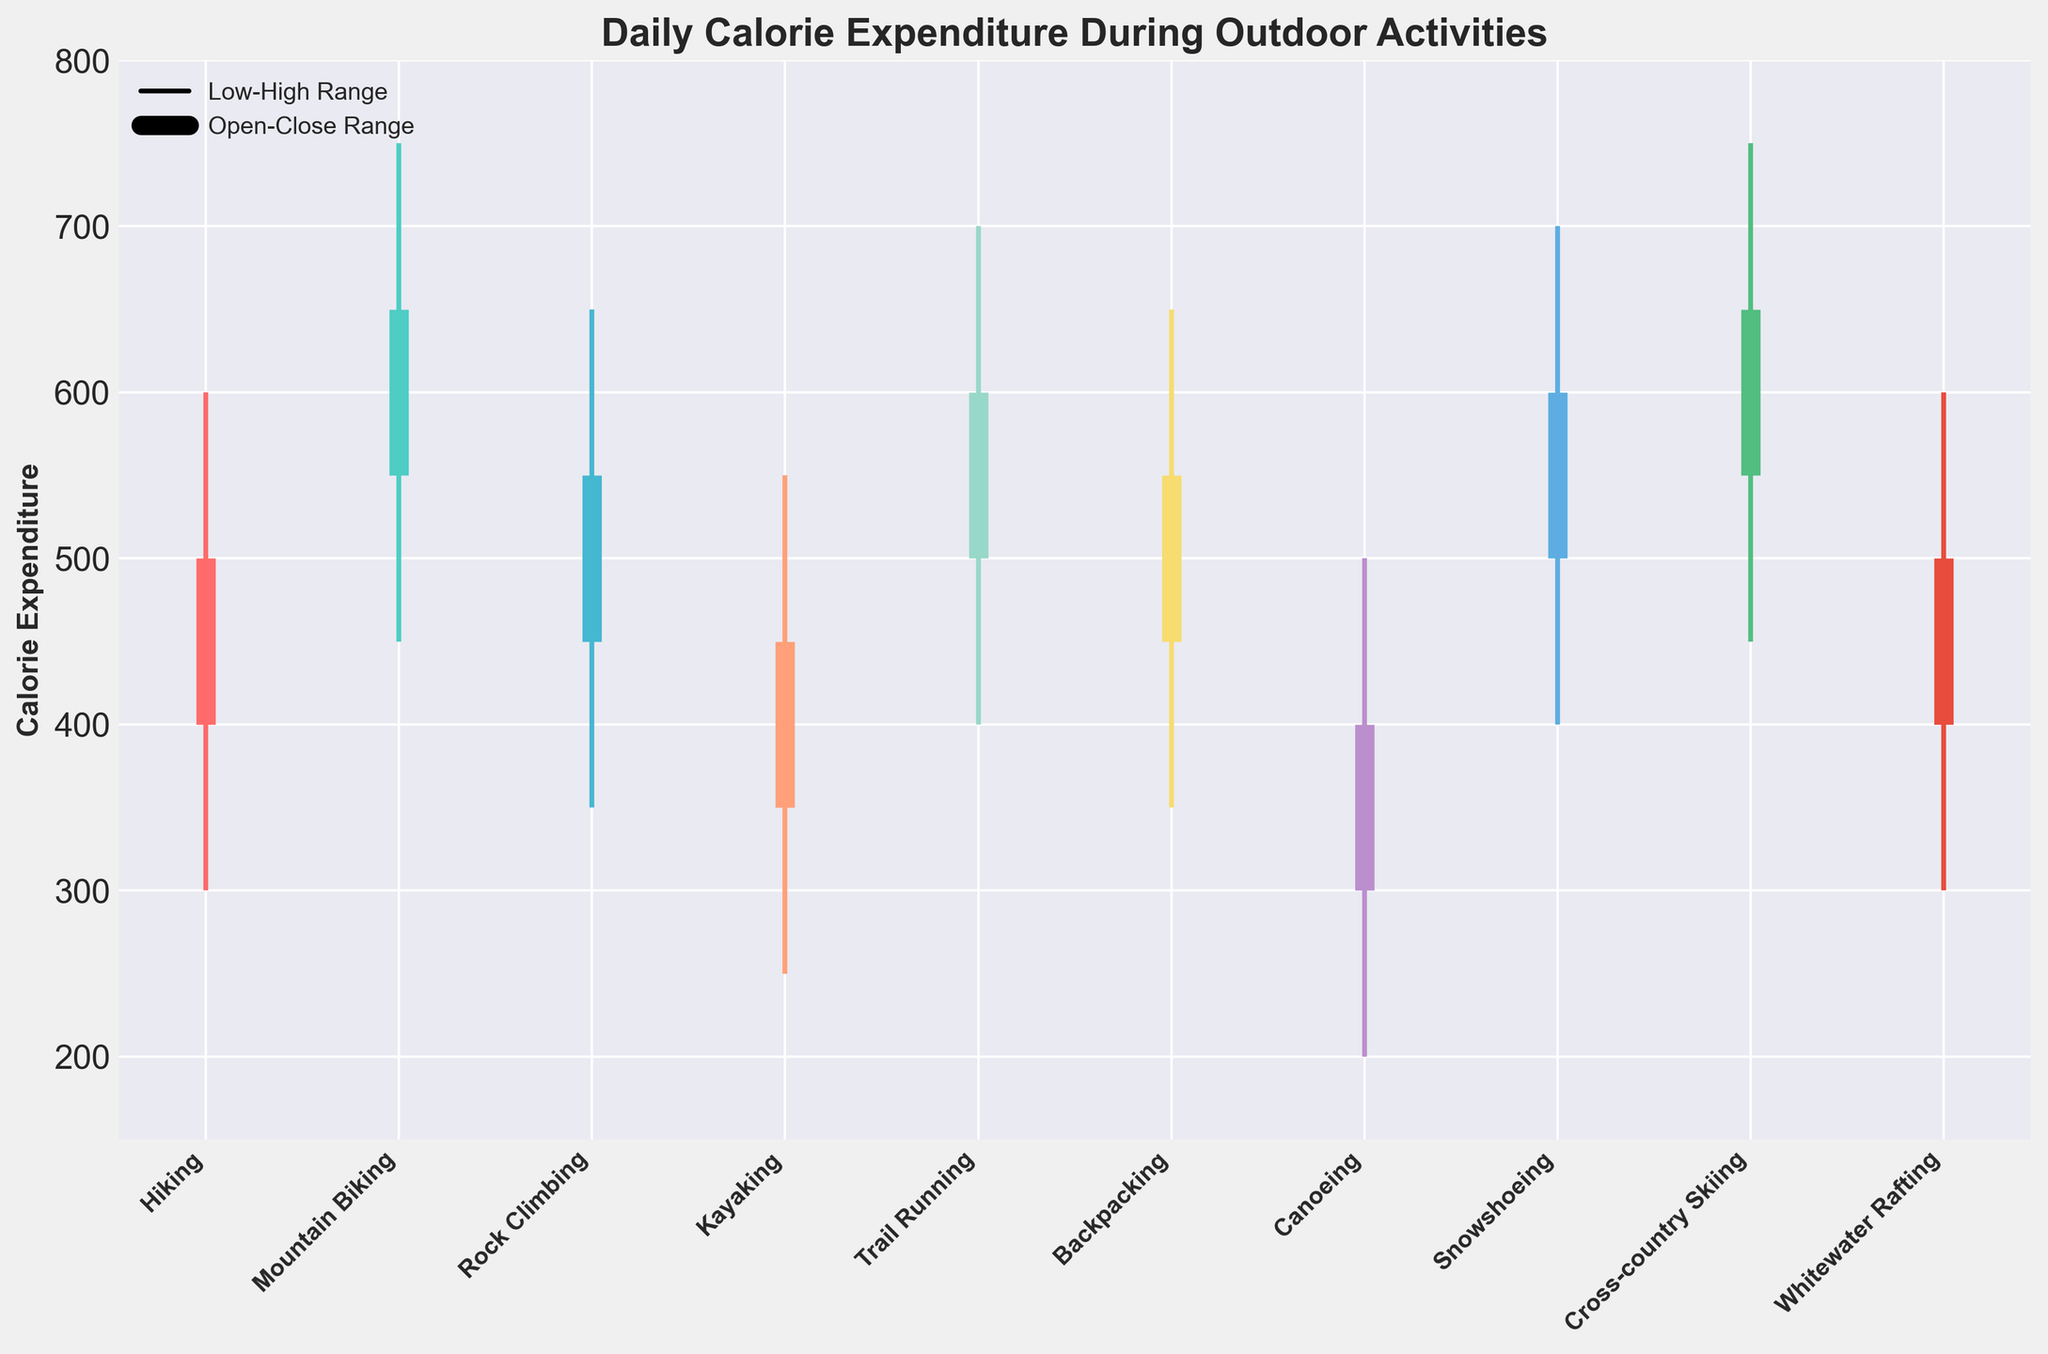What's the title of the figure? The title is located at the top of the figure and reads: 'Daily Calorie Expenditure During Outdoor Activities'
Answer: Daily Calorie Expenditure During Outdoor Activities How many outdoor activities are displayed in the chart? Count the number of labels along the x-axis; each label represents one activity. There are 10 labels.
Answer: 10 What is the calorie expenditure range for Trail Running? Look at the 'Trail Running' bar; the low value is 400, and the high value is 700.
Answer: 400-700 Which activity has the highest high value? Identify the highest vertical line from the figure, which corresponds to Cross-country Skiing and Mountain Biking, both reaching 750 calories.
Answer: Cross-country Skiing, Mountain Biking How many activities have a low value of 450 or more? Check each activity's low value and count those that are 450 or more: Mountain Biking, Cross-country Skiing.
Answer: 2 What's the total calorie expenditure for the lowest values of Kayaking and Canoeing? Add the low values for Kayaking (250) and Canoeing (200): 250 + 200 = 450
Answer: 450 Which activities have a close value of 550? Identify the activities where the close bar meets the 550 mark: Rock Climbing, Backpacking.
Answer: Rock Climbing, Backpacking What’s the difference in high values between Snowshoeing and Whitewater Rafting? Subtract the high value for Whitewater Rafting (600) from Snowshoeing's high value (700): 700 - 600 = 100
Answer: 100 What is the average open value for all activities? Add all open values and divide by the number of activities: (400 + 550 + 450 + 350 + 500 + 450 + 300 + 500 + 550 + 400) / 10 = 4450 / 10 = 445
Answer: 445 Which activity has the smallest range between low and high values? Calculate the range (high - low) for each activity and find the smallest one. Canoeing has the smallest range: 500 - 200 = 300
Answer: Canoeing 